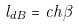<formula> <loc_0><loc_0><loc_500><loc_500>l _ { d B } = c \hbar { \beta }</formula> 